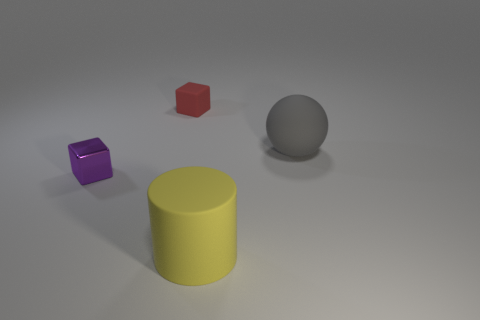Subtract all purple cubes. How many cubes are left? 1 Subtract 1 cylinders. How many cylinders are left? 0 Add 1 yellow things. How many objects exist? 5 Subtract 1 red cubes. How many objects are left? 3 Subtract all cylinders. How many objects are left? 3 Subtract all red blocks. Subtract all cyan spheres. How many blocks are left? 1 Subtract all red balls. How many red cubes are left? 1 Subtract all big brown metal objects. Subtract all tiny purple metal blocks. How many objects are left? 3 Add 2 yellow cylinders. How many yellow cylinders are left? 3 Add 3 gray cylinders. How many gray cylinders exist? 3 